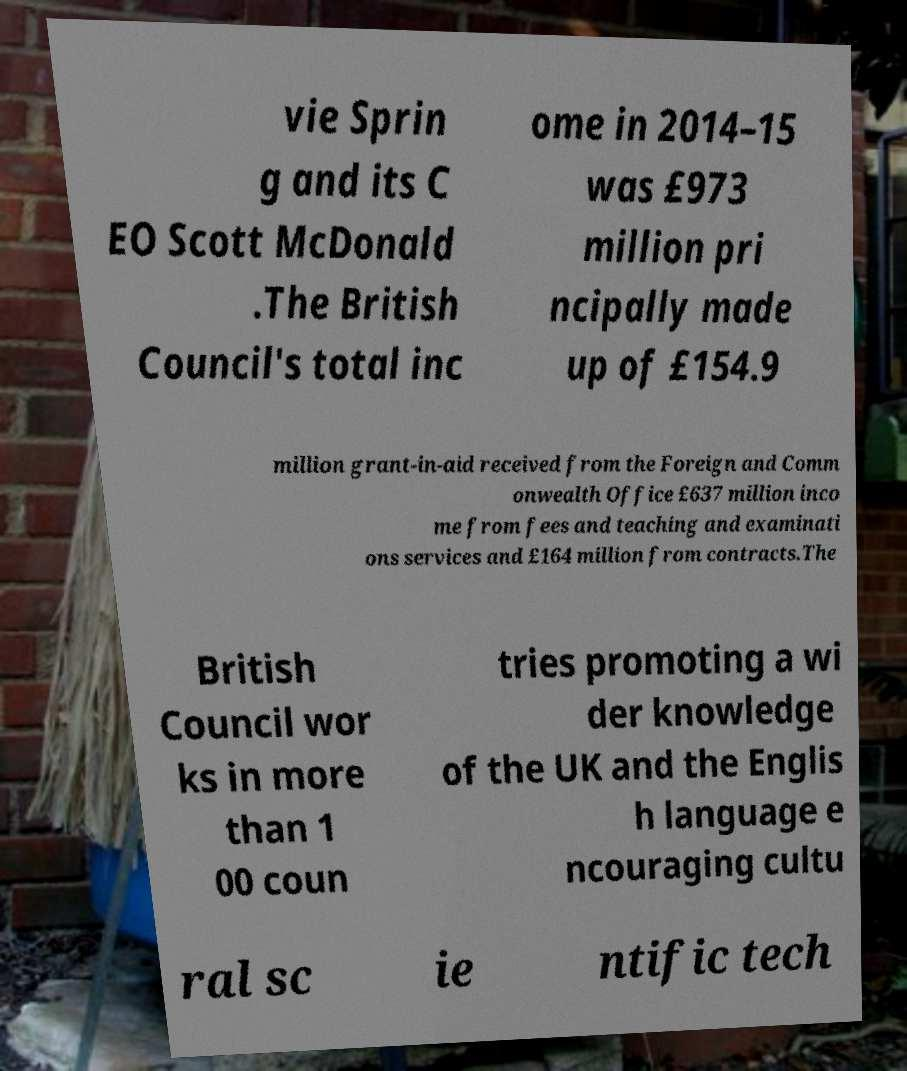I need the written content from this picture converted into text. Can you do that? vie Sprin g and its C EO Scott McDonald .The British Council's total inc ome in 2014–15 was £973 million pri ncipally made up of £154.9 million grant-in-aid received from the Foreign and Comm onwealth Office £637 million inco me from fees and teaching and examinati ons services and £164 million from contracts.The British Council wor ks in more than 1 00 coun tries promoting a wi der knowledge of the UK and the Englis h language e ncouraging cultu ral sc ie ntific tech 